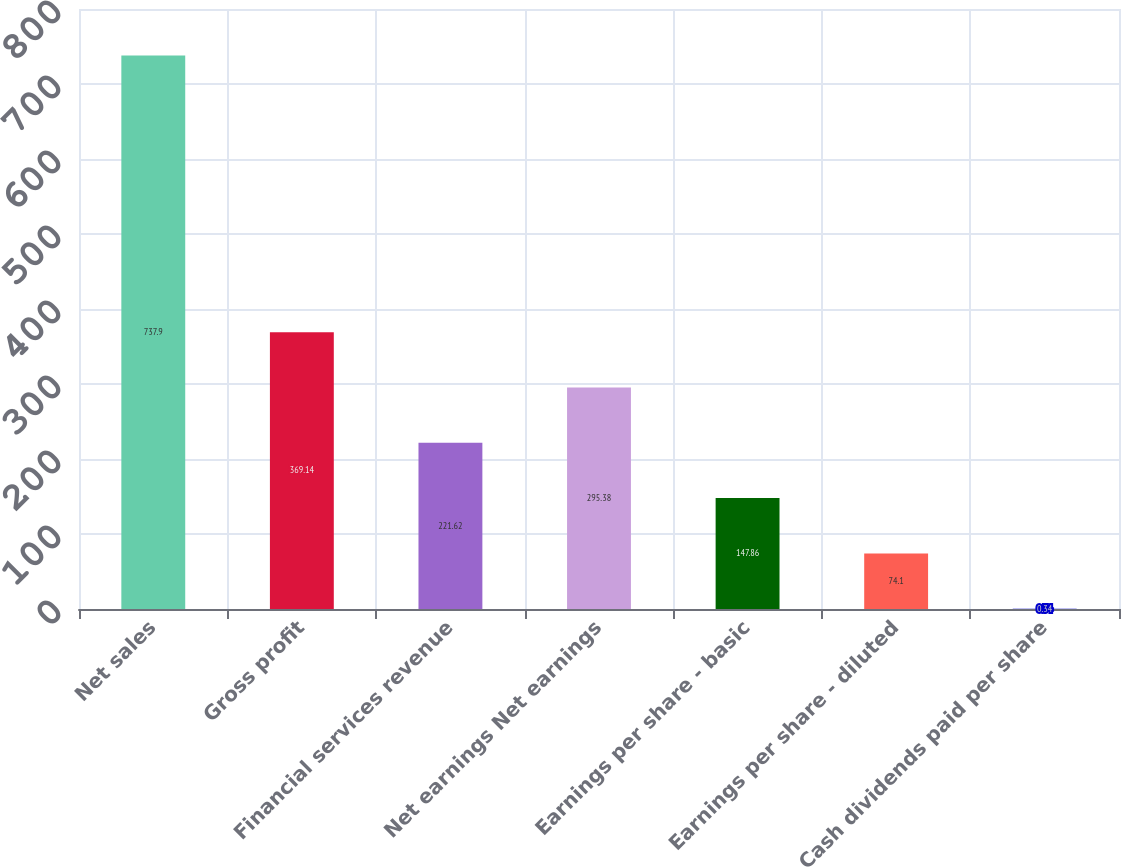Convert chart. <chart><loc_0><loc_0><loc_500><loc_500><bar_chart><fcel>Net sales<fcel>Gross profit<fcel>Financial services revenue<fcel>Net earnings Net earnings<fcel>Earnings per share - basic<fcel>Earnings per share - diluted<fcel>Cash dividends paid per share<nl><fcel>737.9<fcel>369.14<fcel>221.62<fcel>295.38<fcel>147.86<fcel>74.1<fcel>0.34<nl></chart> 